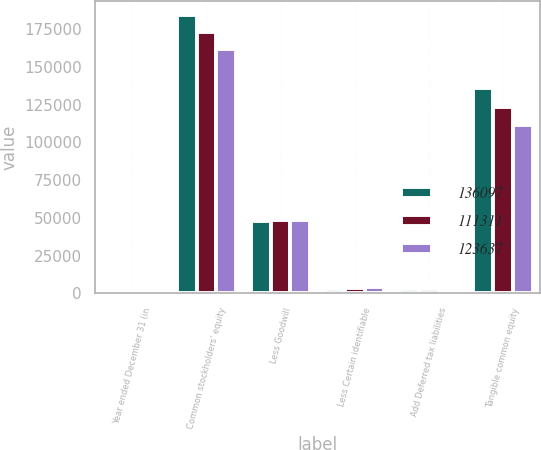Convert chart to OTSL. <chart><loc_0><loc_0><loc_500><loc_500><stacked_bar_chart><ecel><fcel>Year ended December 31 (in<fcel>Common stockholders' equity<fcel>Less Goodwill<fcel>Less Certain identifiable<fcel>Add Deferred tax liabilities<fcel>Tangible common equity<nl><fcel>136097<fcel>2012<fcel>184352<fcel>48176<fcel>2833<fcel>2754<fcel>136097<nl><fcel>111311<fcel>2011<fcel>173266<fcel>48632<fcel>3632<fcel>2635<fcel>123637<nl><fcel>123637<fcel>2010<fcel>161520<fcel>48618<fcel>4178<fcel>2587<fcel>111311<nl></chart> 